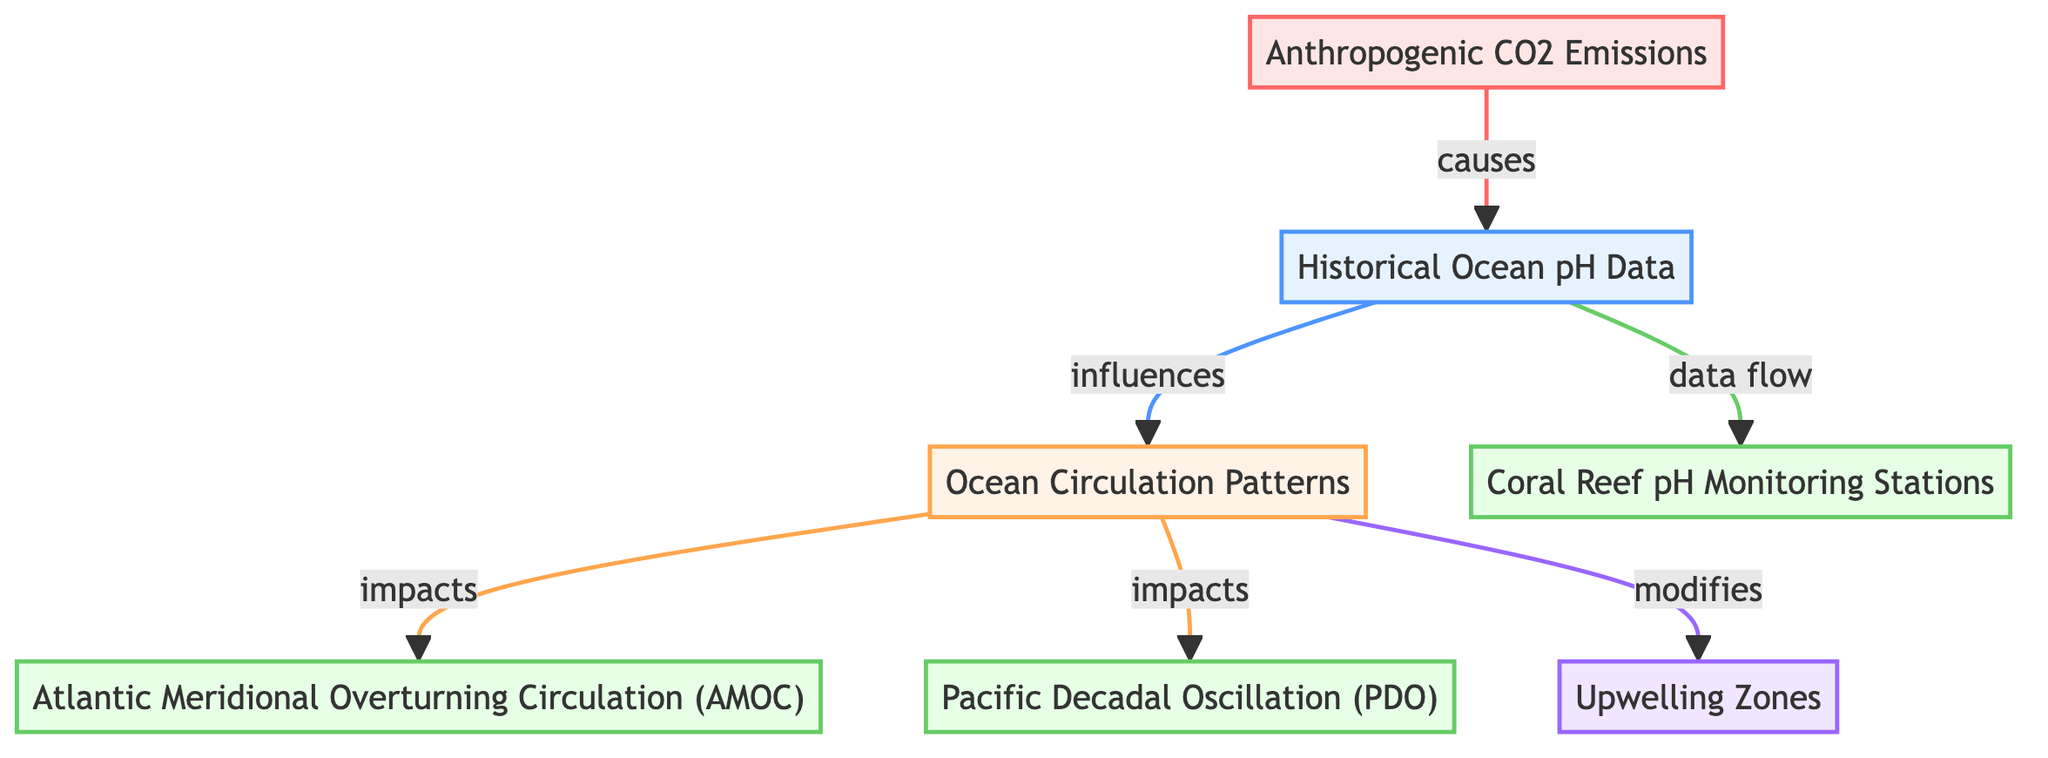What is the main dataset represented in the diagram? The diagram identifies "Historical Ocean pH Data" as the primary dataset node, which is central to the analysis.
Answer: Historical Ocean pH Data How many nodes are present in the diagram? By counting the total distinct elements within the nodes section of the diagram, there are seven nodes displayed.
Answer: Seven What type of relationship exists between "Historical Ocean pH Data" and "Ocean Circulation Patterns"? The diagram links these two nodes with an "influences" relationship, showing that historical pH changes have an impact on ocean circulation.
Answer: Influences Which entity is affected by changes in ocean circulation according to the diagram? Two entities are impacted by changes in ocean circulation: the Atlantic Meridional Overturning Circulation (AMOC) and the Pacific Decadal Oscillation (PDO).
Answer: AMOC, PDO What influences "Historical Ocean pH Data"? The diagram indicates that "Anthropogenic CO2 Emissions" cause changes in Historical Ocean pH Data, thereby leading to acidification.
Answer: Anthropogenic CO2 Emissions What is the connection between "Ocean Circulation Patterns" and "Upwelling Zones"? The diagram illustrates that ocean circulation patterns have a modifying effect on nutrient-rich upwelling zones, showing how circulation changes can influence these regions.
Answer: Modifies How does increased CO2 affect ocean pH levels? The flow of information in the diagram indicates that increased CO2 levels directly lead to a decrease in ocean pH (acidification).
Answer: Causes What type of data flow is indicated from "Historical Ocean pH Data" to "Coral Reef pH Monitoring Stations"? The diagram specifies a data flow relationship, indicating that historical pH data is continuously collected at coral reef monitoring stations.
Answer: Data flow Which oceanic region is highlighted in the diagram? The diagram specifies "Upwelling Zones" as a distinct region, which is crucial for nutrient cycling and is affected by other factors represented.
Answer: Upwelling Zones 